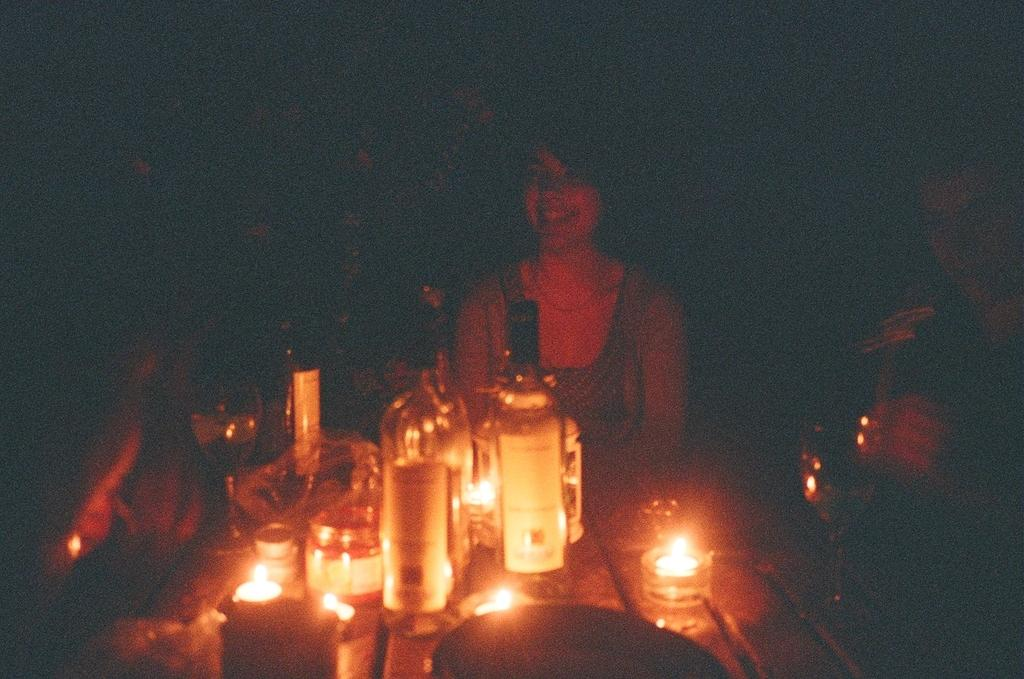What objects are on the table in the image? There are bottles on the table in the image. Can you describe the people in the image? Unfortunately, the image is blurred, so it is difficult to describe the people in detail. What is the overall quality of the image? The image is blurred, which affects its clarity and detail. What type of credit card is visible in the image? There is no credit card present in the image. Can you hear the people in the image crying? The image is a still photograph, so there is no sound or indication of crying. 